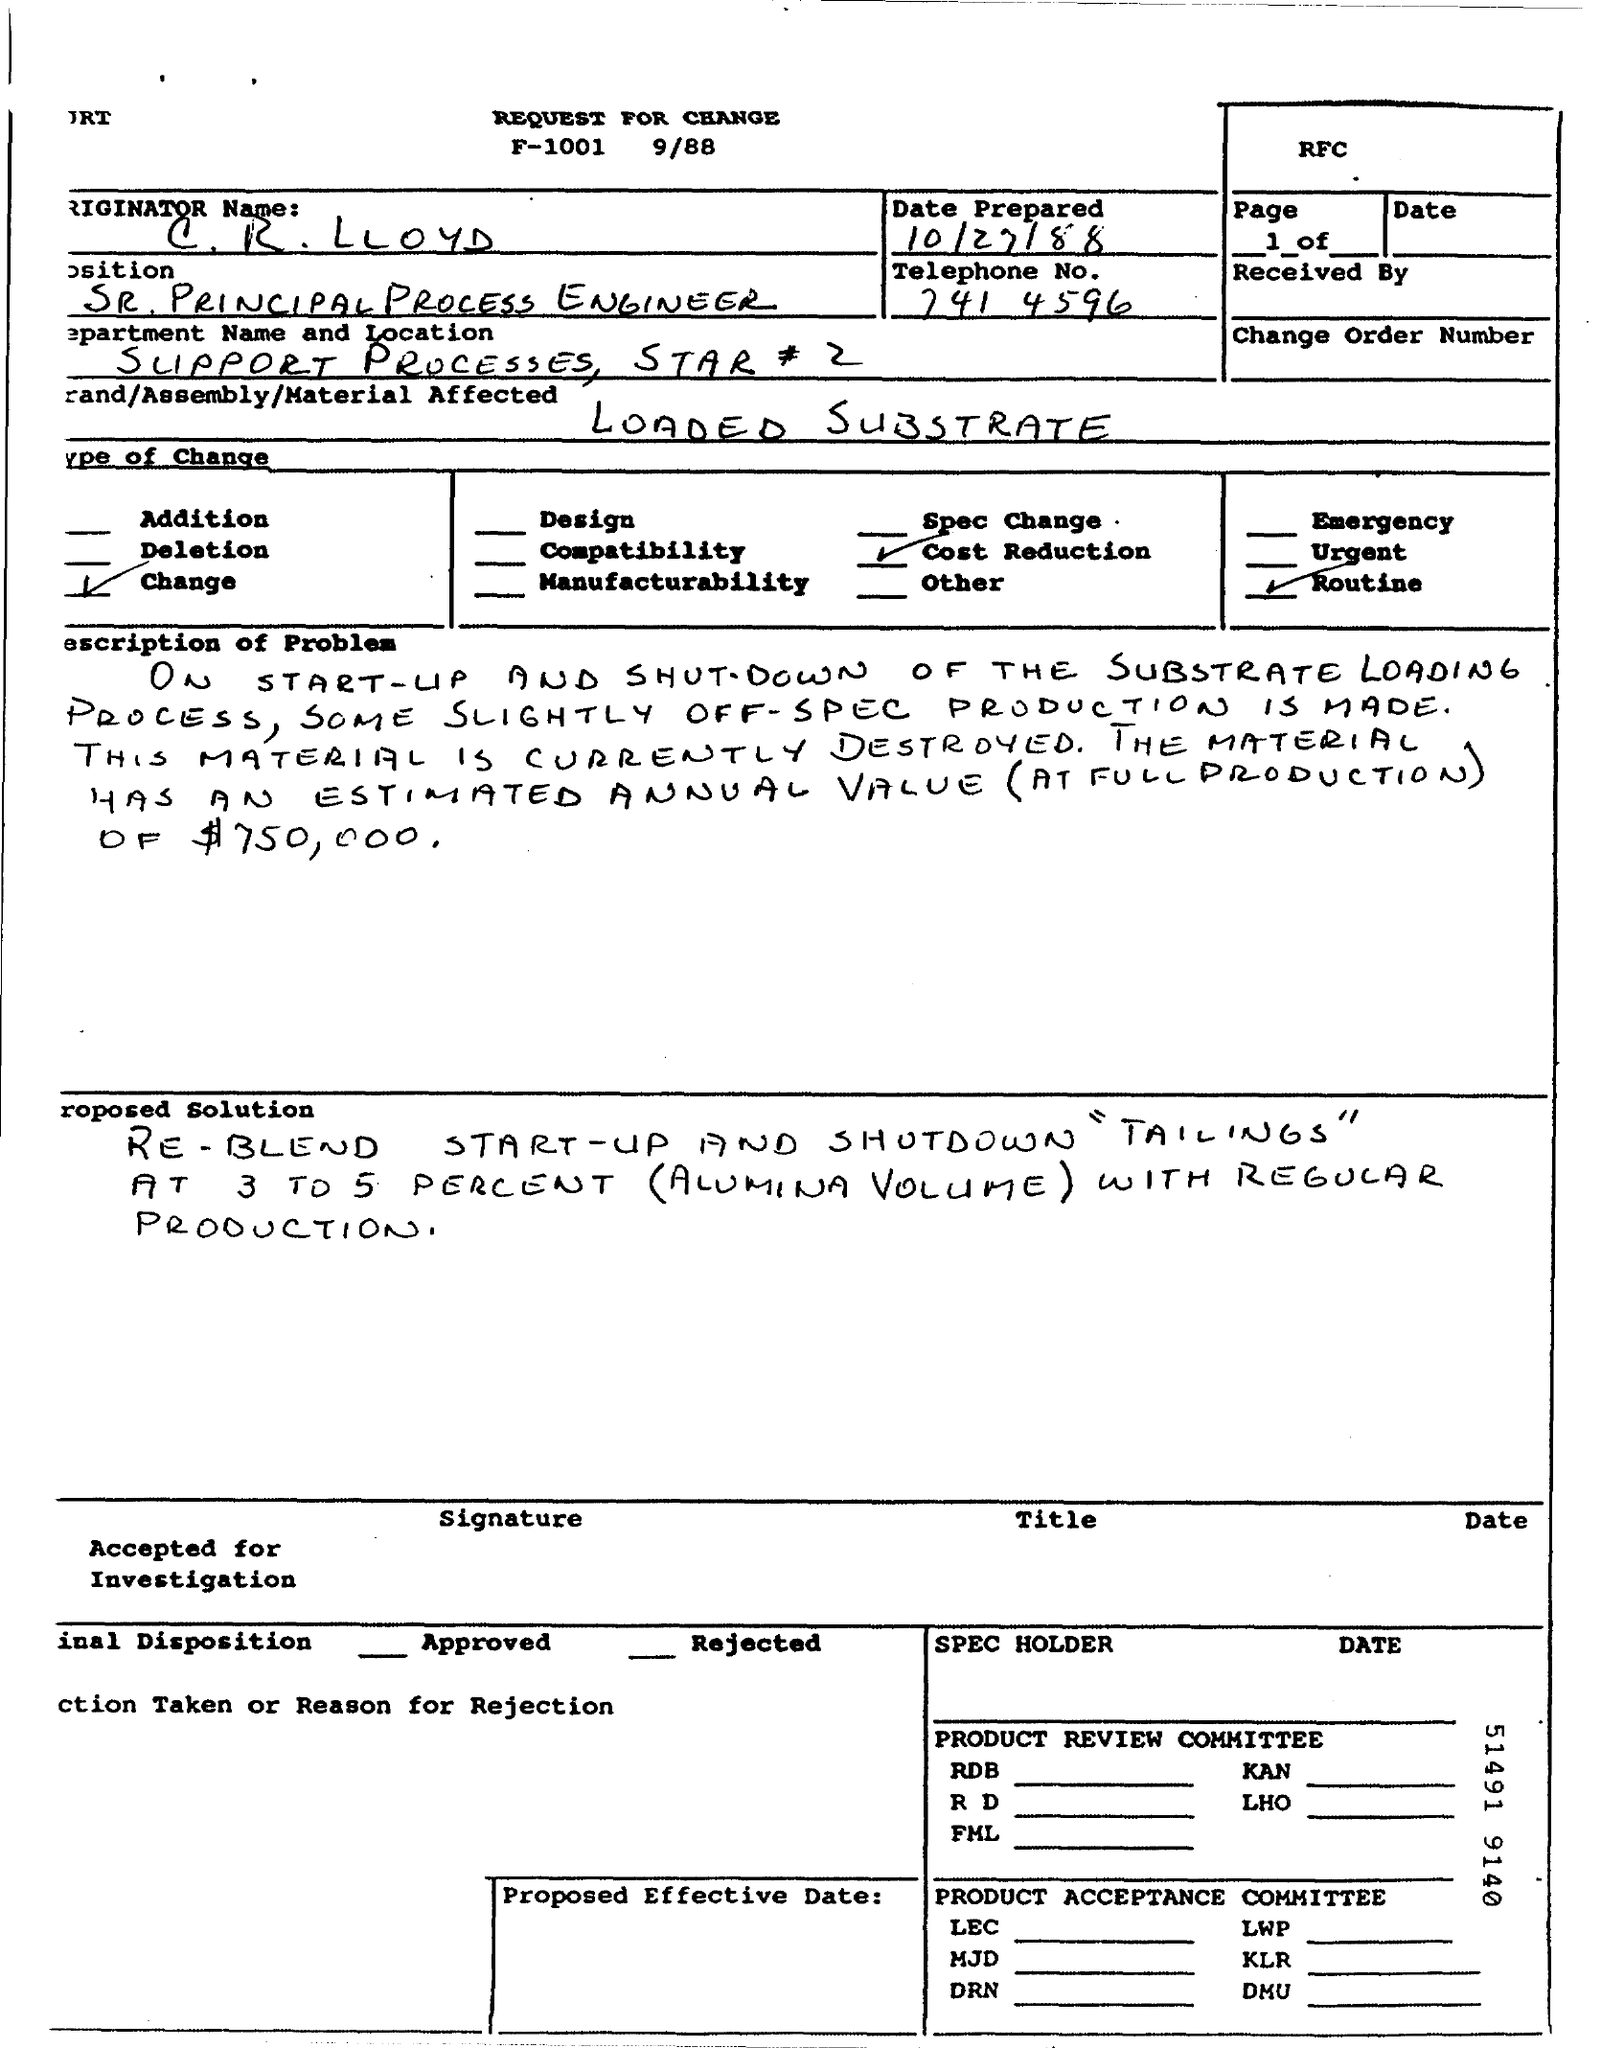What is the name mentioned in the document ?
Your response must be concise. C.R.Lloyd. When is the document prepared ?
Ensure brevity in your answer.  10/27/88. What is the telephone no. given in the document ?
Offer a terse response. 741 4596. What is the position mentioned in the document ?
Keep it short and to the point. Sr. principal process engineer. What is the material affected given in the document ?
Give a very brief answer. Loaded substrate. 